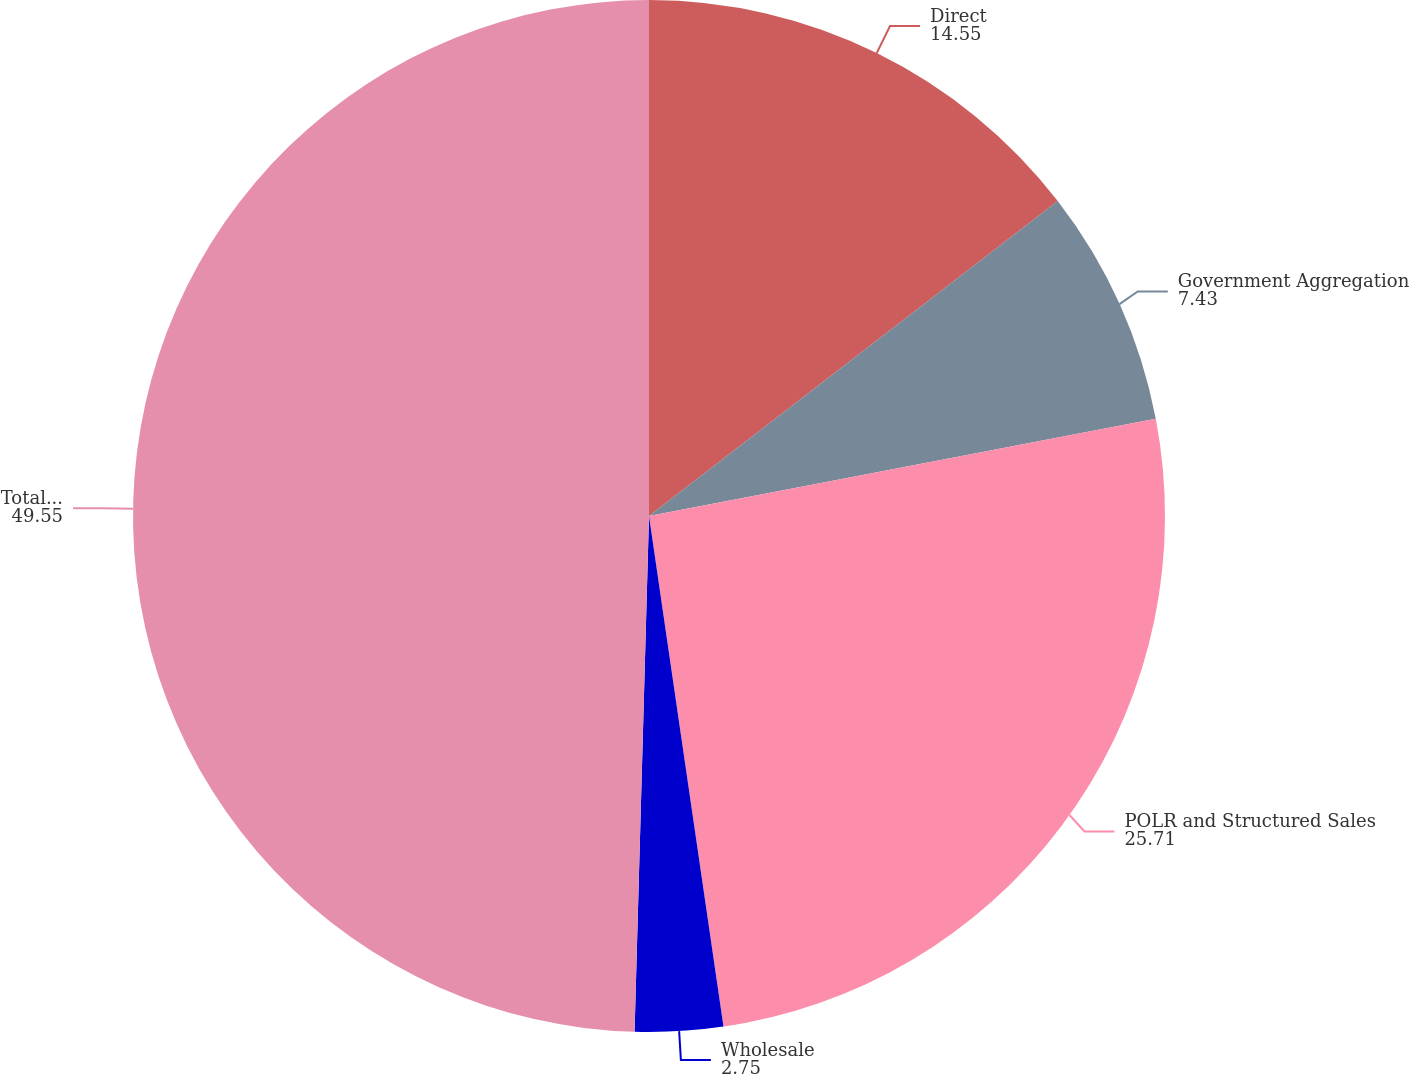<chart> <loc_0><loc_0><loc_500><loc_500><pie_chart><fcel>Direct<fcel>Government Aggregation<fcel>POLR and Structured Sales<fcel>Wholesale<fcel>Total Sales<nl><fcel>14.55%<fcel>7.43%<fcel>25.71%<fcel>2.75%<fcel>49.55%<nl></chart> 